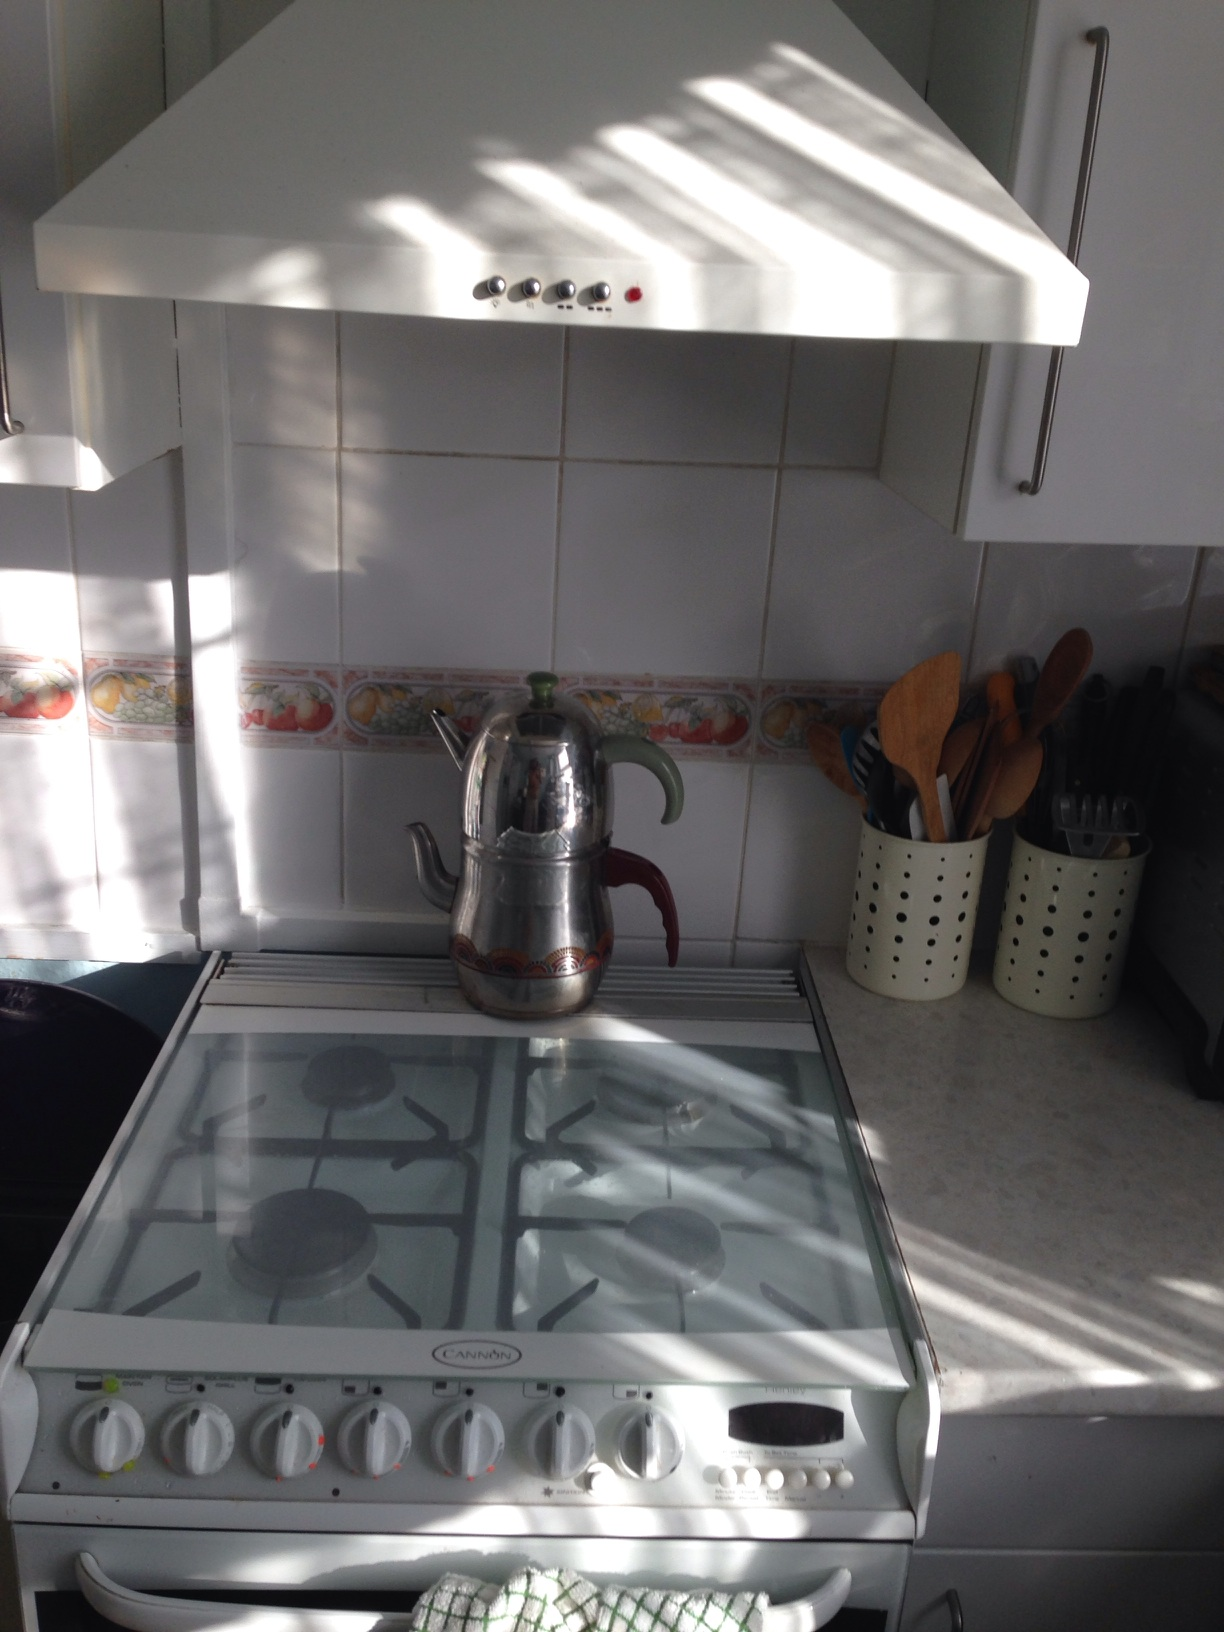What does the light filtering in suggest about the time of day? The light filtering through suggests that it is likely morning or early afternoon. The natural light creates a warm and inviting ambiance, indicating that the sun is high enough to cast clear shadows while illuminating the space thoroughly, possibly through a nearby window. 